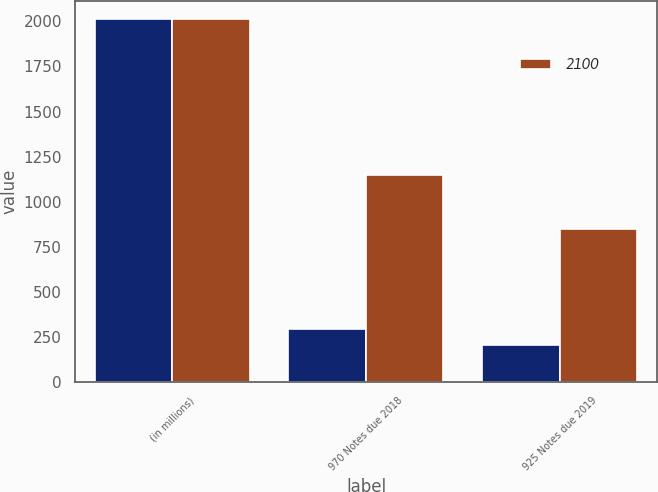Convert chart. <chart><loc_0><loc_0><loc_500><loc_500><stacked_bar_chart><ecel><fcel>(in millions)<fcel>970 Notes due 2018<fcel>925 Notes due 2019<nl><fcel>nan<fcel>2013<fcel>293<fcel>207<nl><fcel>2100<fcel>2012<fcel>1151<fcel>849<nl></chart> 